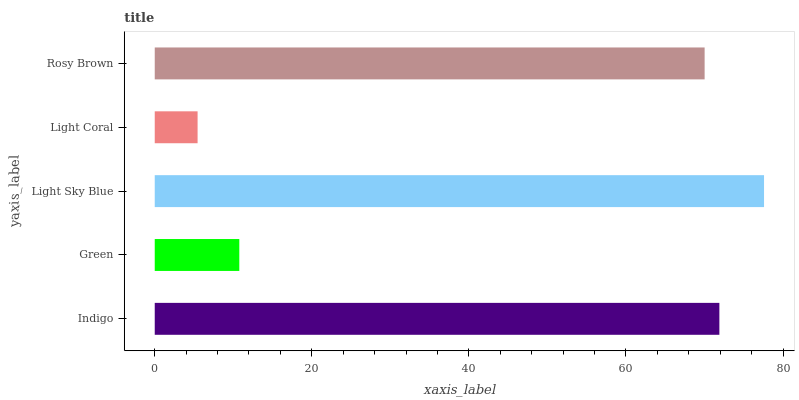Is Light Coral the minimum?
Answer yes or no. Yes. Is Light Sky Blue the maximum?
Answer yes or no. Yes. Is Green the minimum?
Answer yes or no. No. Is Green the maximum?
Answer yes or no. No. Is Indigo greater than Green?
Answer yes or no. Yes. Is Green less than Indigo?
Answer yes or no. Yes. Is Green greater than Indigo?
Answer yes or no. No. Is Indigo less than Green?
Answer yes or no. No. Is Rosy Brown the high median?
Answer yes or no. Yes. Is Rosy Brown the low median?
Answer yes or no. Yes. Is Light Coral the high median?
Answer yes or no. No. Is Light Coral the low median?
Answer yes or no. No. 